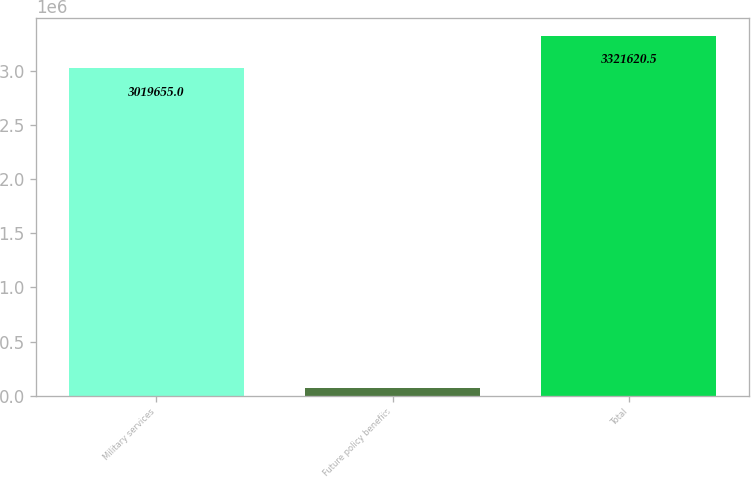Convert chart. <chart><loc_0><loc_0><loc_500><loc_500><bar_chart><fcel>Military services<fcel>Future policy benefits<fcel>Total<nl><fcel>3.01966e+06<fcel>73130<fcel>3.32162e+06<nl></chart> 